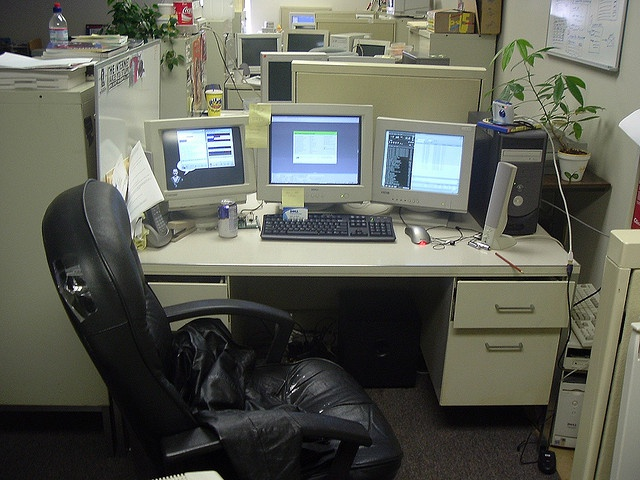Describe the objects in this image and their specific colors. I can see chair in black, gray, and purple tones, tv in black, darkgray, gray, and lightblue tones, potted plant in black, darkgray, gray, and darkgreen tones, tv in black, gray, and lightblue tones, and tv in black, darkgray, gray, and lightblue tones in this image. 